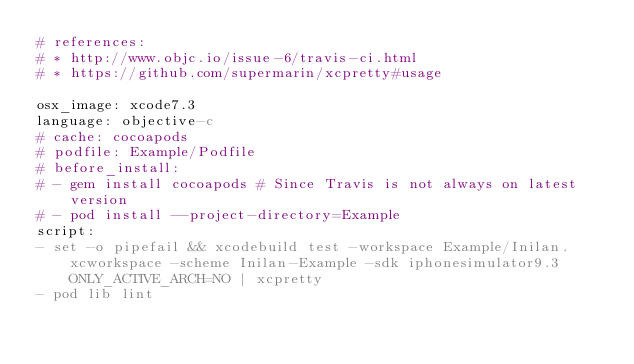<code> <loc_0><loc_0><loc_500><loc_500><_YAML_># references:
# * http://www.objc.io/issue-6/travis-ci.html
# * https://github.com/supermarin/xcpretty#usage

osx_image: xcode7.3
language: objective-c
# cache: cocoapods
# podfile: Example/Podfile
# before_install:
# - gem install cocoapods # Since Travis is not always on latest version
# - pod install --project-directory=Example
script:
- set -o pipefail && xcodebuild test -workspace Example/Inilan.xcworkspace -scheme Inilan-Example -sdk iphonesimulator9.3 ONLY_ACTIVE_ARCH=NO | xcpretty
- pod lib lint
</code> 